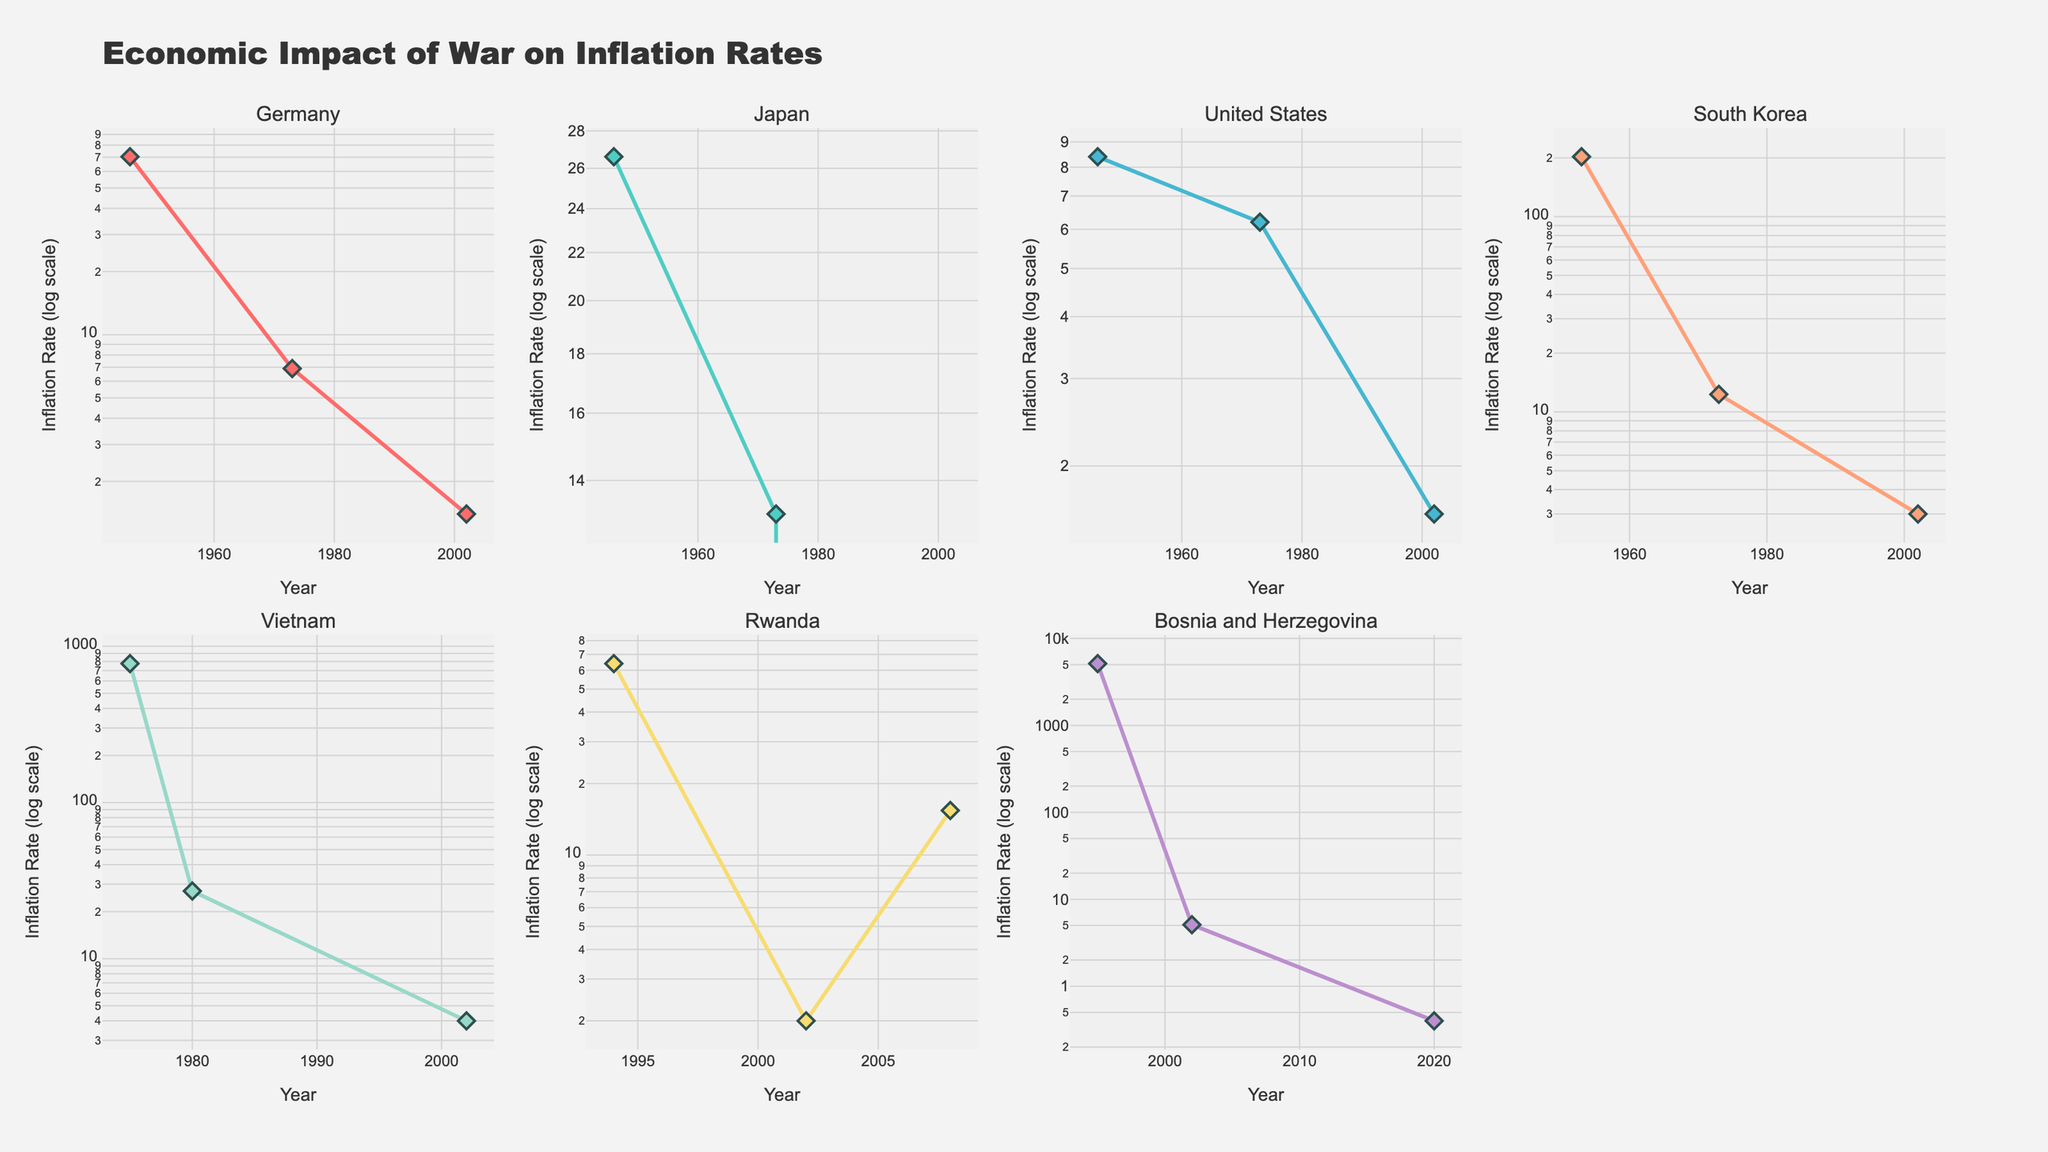How many countries are displayed in the figure? The figure contains subplots for each unique country represented in the data. By counting the subplot titles, we can determine the number of countries. There are 7 unique countries.
Answer: 7 What is the title of the figure? The title is displayed prominently at the top of the figure. It is "Economic Impact of War on Inflation Rates."
Answer: Economic Impact of War on Inflation Rates Which country experienced the highest inflation rate, and in what year did it occur? By inspecting the Y values in the subplots, we can identify the highest inflation rate. Bosnia and Herzegovina had the highest rate of 5128.3 in 1995.
Answer: Bosnia and Herzegovina, 1995 Between 1946 and 2002, which country had the highest decrease in inflation rate? We need to compare the inflation rates for each country in 1946 and 2002 and calculate the decrease. Germany had a decrease from 70.4 in 1946 to 1.4 in 2002, which is the largest decrease.
Answer: Germany How did South Korea's inflation rate change from 1953 to 1973? Inspecting South Korea's subplot, the inflation rate decreased from 202.7 in 1953 to 12.3 in 1973.
Answer: It decreased Compare Japan's and the United States' inflation rates in 1973. Which country had a higher rate and by how much? Refer to the subplots for Japan and the United States for 1973. Japan had an inflation rate of 13.1, whereas the United States had 6.2. Japan's rate was 6.9 higher than the United States'.
Answer: Japan, by 6.9 How does the inflation rate trend in Rwanda between 1994 and 2002 compare to the trend between 2002 and 2008? In the first period, Rwanda's inflation rate decreased from 64.0 in 1994 to 2.0 in 2002. In the second period, it increased from 2.0 in 2002 to 15.4 in 2008.
Answer: Decreased then increased Which country has the least volatile inflation rate across the given years? By examining the subplots, Germany shows the least volatility with relatively stable inflation rates compared to others.
Answer: Germany What is the inflation rate of Vietnam in 2002 and how does it compare to the inflation rate in 1975? Inspecting Vietnam's subplot, the inflation rate in 2002 was 4.0 and in 1975 it was 774.7. The inflation rate in 2002 is much lower.
Answer: 4.0, much lower than 774.7 